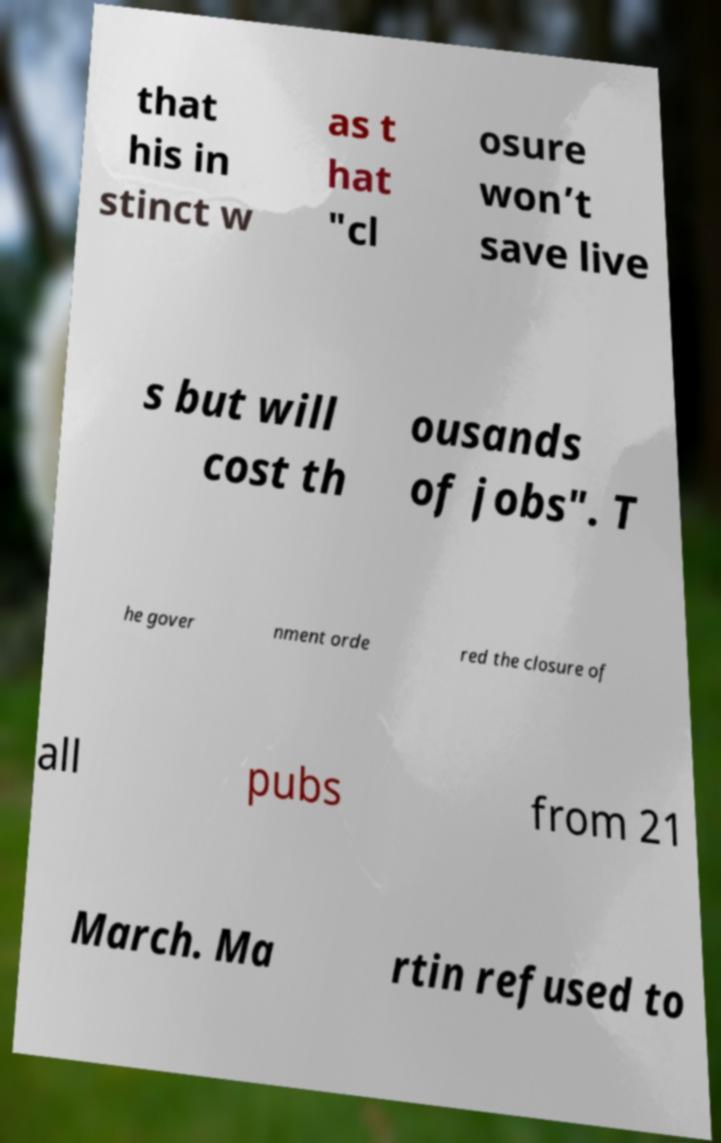Could you extract and type out the text from this image? that his in stinct w as t hat "cl osure won’t save live s but will cost th ousands of jobs". T he gover nment orde red the closure of all pubs from 21 March. Ma rtin refused to 